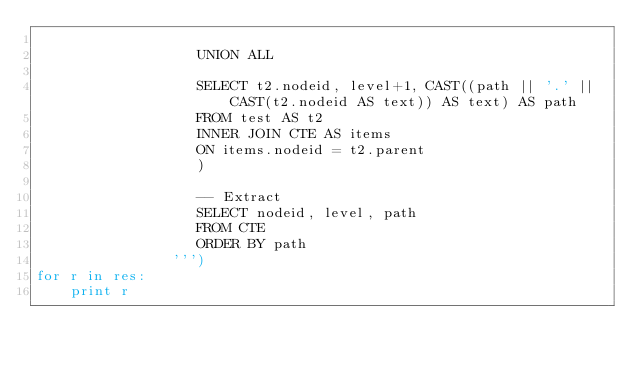Convert code to text. <code><loc_0><loc_0><loc_500><loc_500><_Python_>
                   UNION ALL

                   SELECT t2.nodeid, level+1, CAST((path || '.' || CAST(t2.nodeid AS text)) AS text) AS path
                   FROM test AS t2
                   INNER JOIN CTE AS items
                   ON items.nodeid = t2.parent
                   )

                   -- Extract
                   SELECT nodeid, level, path
                   FROM CTE
                   ORDER BY path
                ''')
for r in res:
    print r
</code> 